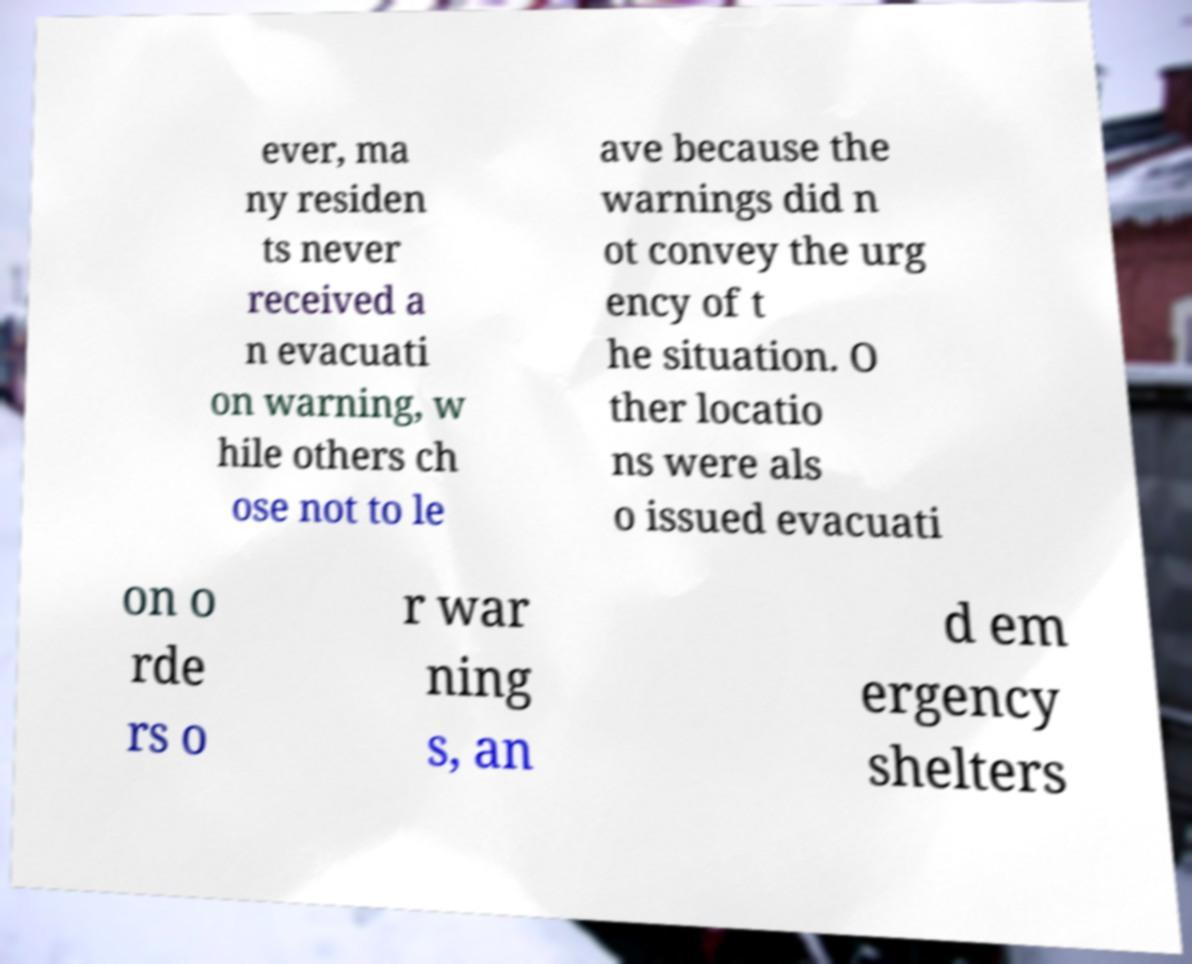What messages or text are displayed in this image? I need them in a readable, typed format. ever, ma ny residen ts never received a n evacuati on warning, w hile others ch ose not to le ave because the warnings did n ot convey the urg ency of t he situation. O ther locatio ns were als o issued evacuati on o rde rs o r war ning s, an d em ergency shelters 